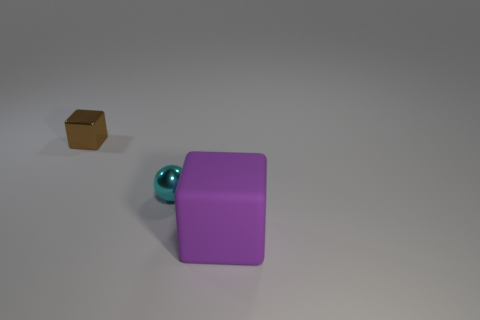Add 2 small blue cubes. How many objects exist? 5 Subtract all cubes. How many objects are left? 1 Subtract all cyan cubes. Subtract all brown cubes. How many objects are left? 2 Add 1 tiny blocks. How many tiny blocks are left? 2 Add 2 big gray metallic cubes. How many big gray metallic cubes exist? 2 Subtract 0 red balls. How many objects are left? 3 